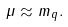Convert formula to latex. <formula><loc_0><loc_0><loc_500><loc_500>\mu \approx m _ { q } .</formula> 